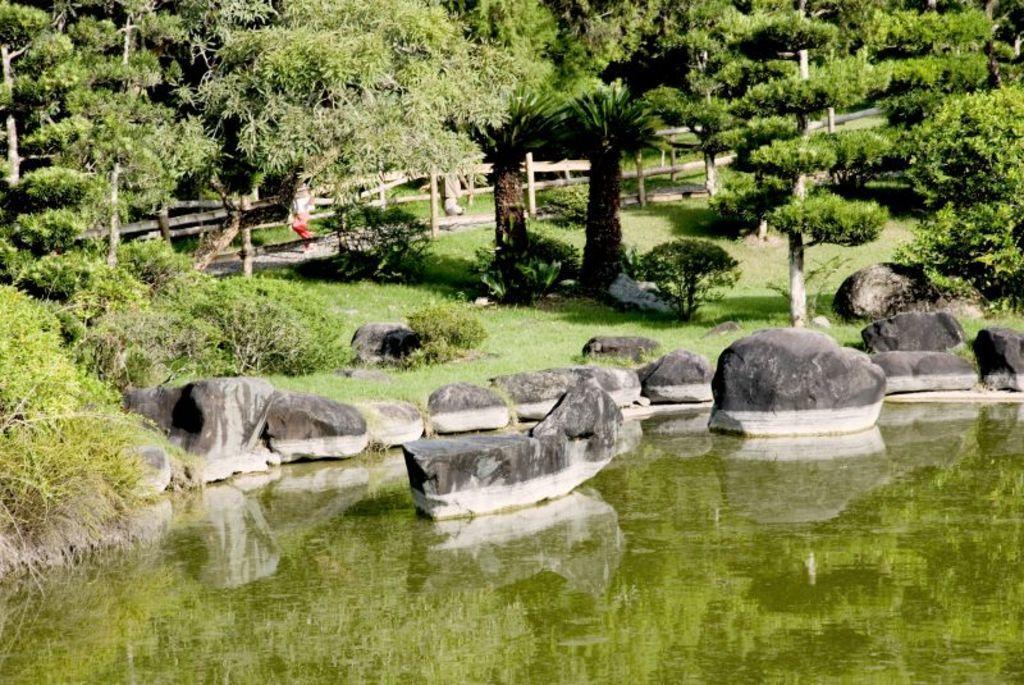Could you give a brief overview of what you see in this image? In this image we can see few trees, plants, grass, stones, water, fence and two persons walking on the pavement. 